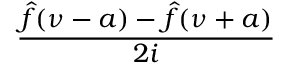<formula> <loc_0><loc_0><loc_500><loc_500>\frac { { \hat { f } } ( \nu - a ) - { \hat { f } } ( \nu + a ) } { 2 i }</formula> 